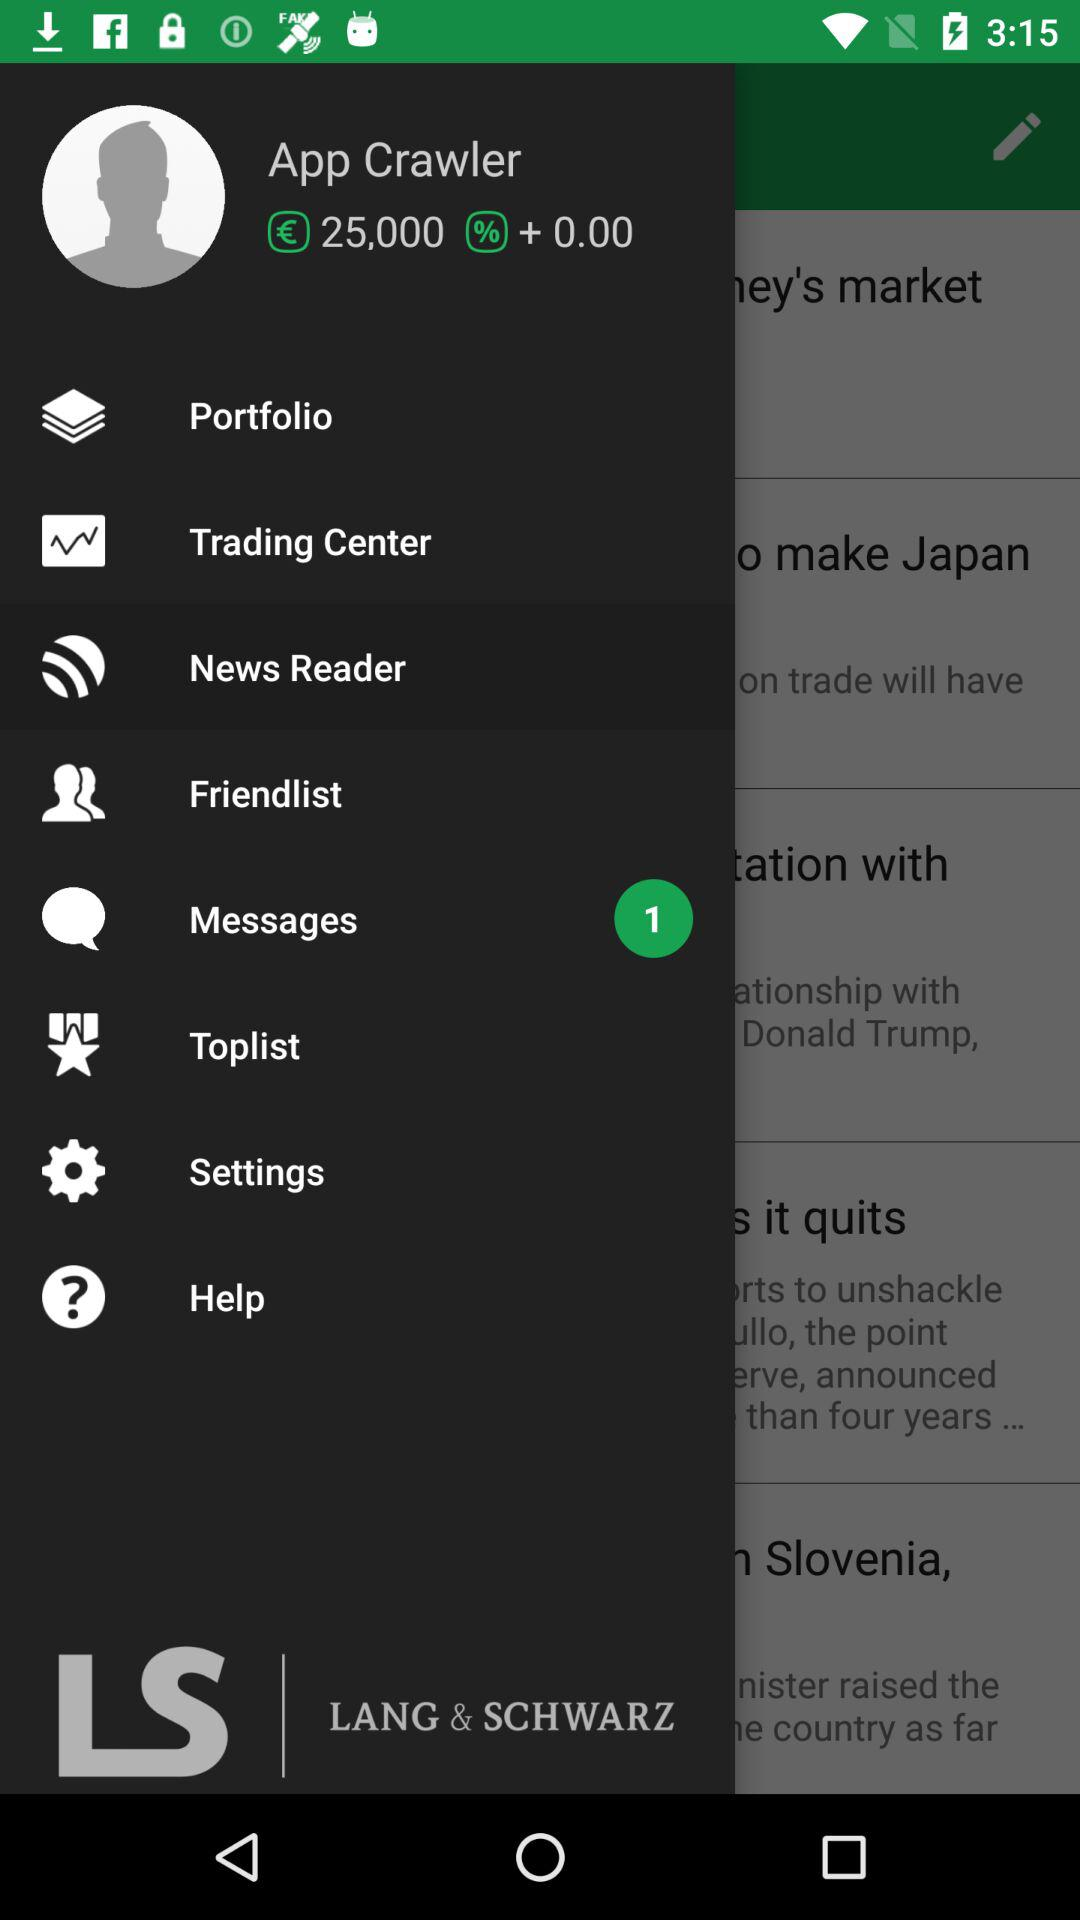How many unread messages are there? There is 1 unread message. 